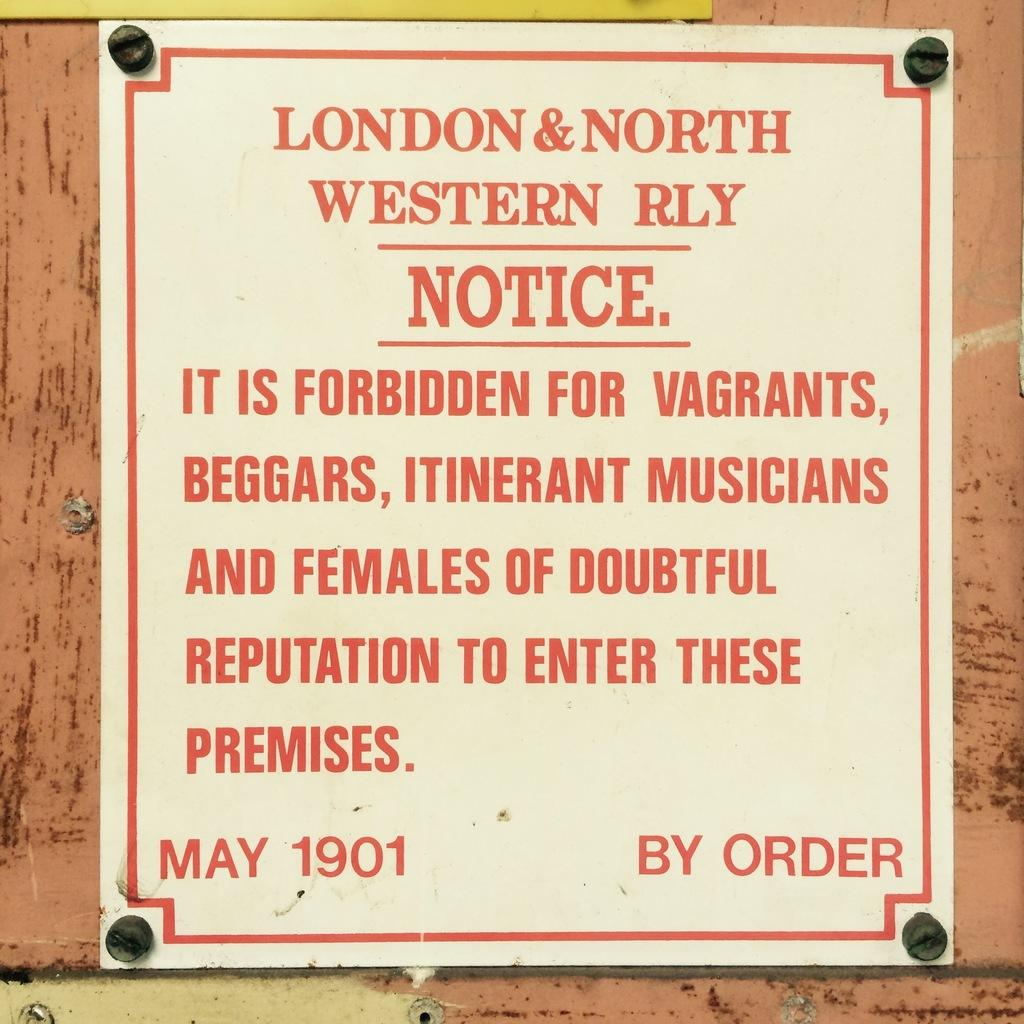Provide a one-sentence caption for the provided image. A red and white sign forbids vagrants from entering the premises. 